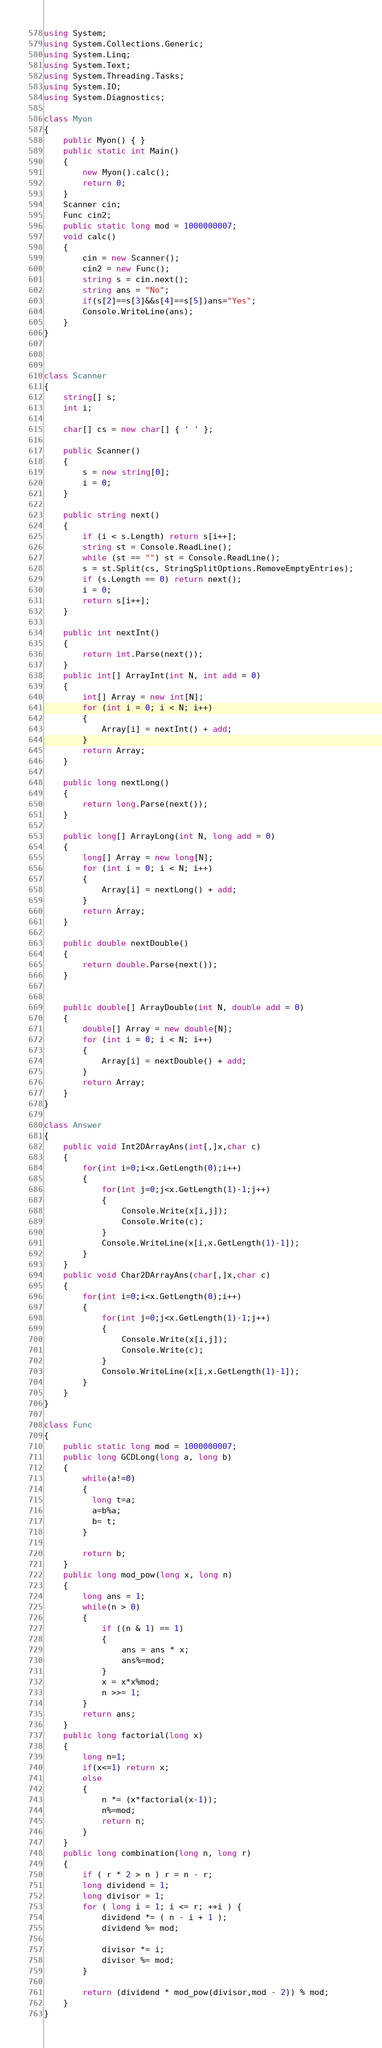Convert code to text. <code><loc_0><loc_0><loc_500><loc_500><_C#_>using System;
using System.Collections.Generic;
using System.Linq;
using System.Text;
using System.Threading.Tasks;
using System.IO;
using System.Diagnostics;

class Myon
{
    public Myon() { }
    public static int Main()
    {
        new Myon().calc();
        return 0;
    }
    Scanner cin;
    Func cin2;
    public static long mod = 1000000007;
    void calc()
    {
        cin = new Scanner();
        cin2 = new Func();
        string s = cin.next();
        string ans = "No";
        if(s[2]==s[3]&&s[4]==s[5])ans="Yes";
        Console.WriteLine(ans);
    }
}



class Scanner
{
    string[] s;
    int i;

    char[] cs = new char[] { ' ' };

    public Scanner()
    {
        s = new string[0];
        i = 0;
    }

    public string next()
    {
        if (i < s.Length) return s[i++];
        string st = Console.ReadLine();
        while (st == "") st = Console.ReadLine();
        s = st.Split(cs, StringSplitOptions.RemoveEmptyEntries);
        if (s.Length == 0) return next();
        i = 0;
        return s[i++];
    }

    public int nextInt()
    {
        return int.Parse(next());
    }
    public int[] ArrayInt(int N, int add = 0)
    {
        int[] Array = new int[N];
        for (int i = 0; i < N; i++)
        {
            Array[i] = nextInt() + add;
        }
        return Array;
    }

    public long nextLong()
    {
        return long.Parse(next());
    }

    public long[] ArrayLong(int N, long add = 0)
    {
        long[] Array = new long[N];
        for (int i = 0; i < N; i++)
        {
            Array[i] = nextLong() + add;
        }
        return Array;
    }

    public double nextDouble()
    {
        return double.Parse(next());
    }


    public double[] ArrayDouble(int N, double add = 0)
    {
        double[] Array = new double[N];
        for (int i = 0; i < N; i++)
        {
            Array[i] = nextDouble() + add;
        }
        return Array;
    }
}

class Answer
{
    public void Int2DArrayAns(int[,]x,char c)
    {
        for(int i=0;i<x.GetLength(0);i++)
        {
            for(int j=0;j<x.GetLength(1)-1;j++)
            {
                Console.Write(x[i,j]);
                Console.Write(c);
            }
            Console.WriteLine(x[i,x.GetLength(1)-1]);
        }
    }
    public void Char2DArrayAns(char[,]x,char c)
    {
        for(int i=0;i<x.GetLength(0);i++)
        {
            for(int j=0;j<x.GetLength(1)-1;j++)
            {
                Console.Write(x[i,j]);
                Console.Write(c);
            }
            Console.WriteLine(x[i,x.GetLength(1)-1]);
        }
    }
}

class Func
{
    public static long mod = 1000000007;
    public long GCDLong(long a, long b)
    {
        while(a!=0)
        {
          long t=a;
          a=b%a;
          b= t;
        }
      
        return b;        
    }
    public long mod_pow(long x, long n)
    { 
        long ans = 1;
        while(n > 0)
        {
            if ((n & 1) == 1)
            {
                ans = ans * x;
                ans%=mod;
            }
            x = x*x%mod;
            n >>= 1;
        }
        return ans;
    }
    public long factorial(long x)
    {
        long n=1;
        if(x<=1) return x;
        else
        {
            n *= (x*factorial(x-1));
            n%=mod;
            return n;
        }
    }
    public long combination(long n, long r)
    {
        if ( r * 2 > n ) r = n - r;
		long dividend = 1;
		long divisor = 1;
		for ( long i = 1; i <= r; ++i ) {
			dividend *= ( n - i + 1 );
			dividend %= mod;
 
			divisor *= i;
			divisor %= mod;
		}
 
		return (dividend * mod_pow(divisor,mod - 2)) % mod;   
    }
}


</code> 